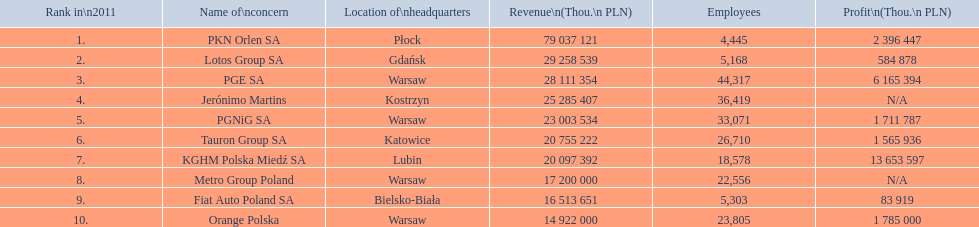Which company had the least revenue? Orange Polska. 